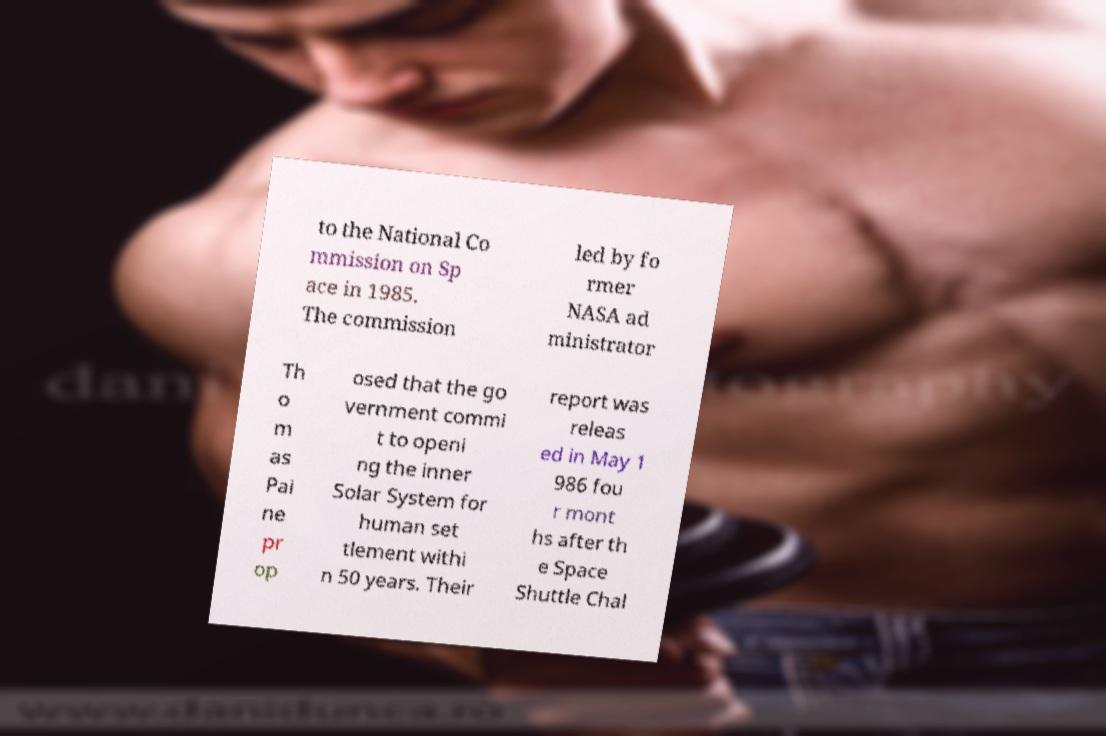What messages or text are displayed in this image? I need them in a readable, typed format. to the National Co mmission on Sp ace in 1985. The commission led by fo rmer NASA ad ministrator Th o m as Pai ne pr op osed that the go vernment commi t to openi ng the inner Solar System for human set tlement withi n 50 years. Their report was releas ed in May 1 986 fou r mont hs after th e Space Shuttle Chal 